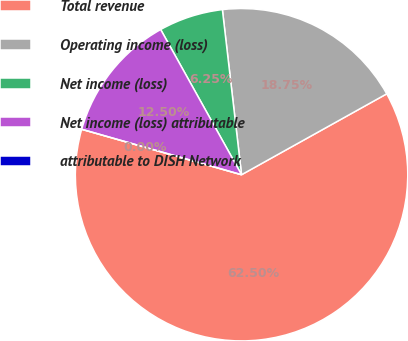<chart> <loc_0><loc_0><loc_500><loc_500><pie_chart><fcel>Total revenue<fcel>Operating income (loss)<fcel>Net income (loss)<fcel>Net income (loss) attributable<fcel>attributable to DISH Network<nl><fcel>62.5%<fcel>18.75%<fcel>6.25%<fcel>12.5%<fcel>0.0%<nl></chart> 